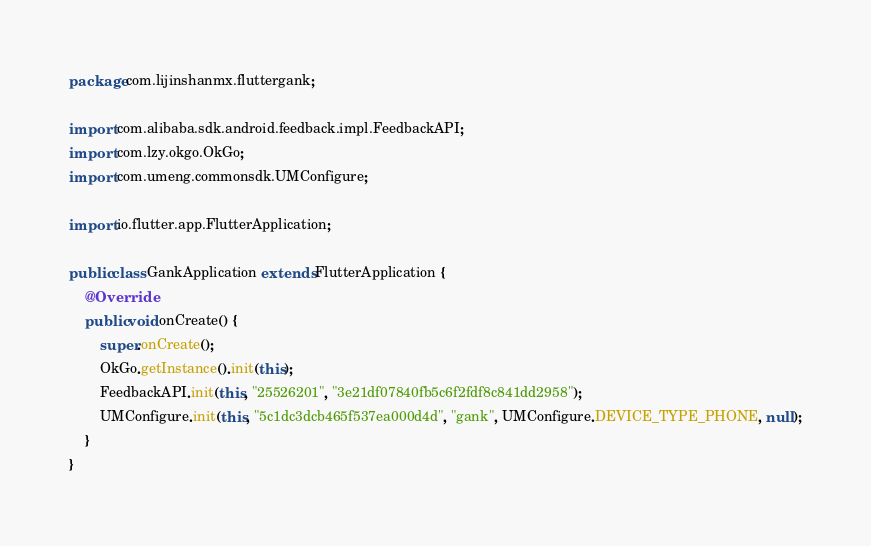<code> <loc_0><loc_0><loc_500><loc_500><_Java_>package com.lijinshanmx.fluttergank;

import com.alibaba.sdk.android.feedback.impl.FeedbackAPI;
import com.lzy.okgo.OkGo;
import com.umeng.commonsdk.UMConfigure;

import io.flutter.app.FlutterApplication;

public class GankApplication extends FlutterApplication {
    @Override
    public void onCreate() {
        super.onCreate();
        OkGo.getInstance().init(this);
        FeedbackAPI.init(this, "25526201", "3e21df07840fb5c6f2fdf8c841dd2958");
        UMConfigure.init(this, "5c1dc3dcb465f537ea000d4d", "gank", UMConfigure.DEVICE_TYPE_PHONE, null);
    }
}
</code> 